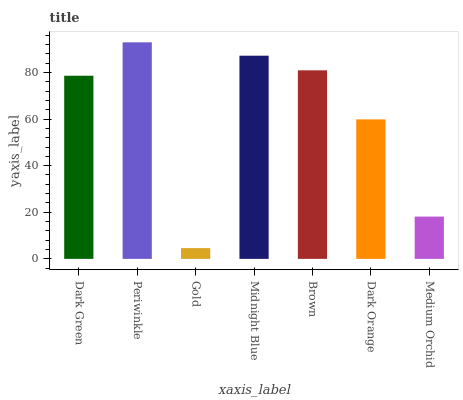Is Gold the minimum?
Answer yes or no. Yes. Is Periwinkle the maximum?
Answer yes or no. Yes. Is Periwinkle the minimum?
Answer yes or no. No. Is Gold the maximum?
Answer yes or no. No. Is Periwinkle greater than Gold?
Answer yes or no. Yes. Is Gold less than Periwinkle?
Answer yes or no. Yes. Is Gold greater than Periwinkle?
Answer yes or no. No. Is Periwinkle less than Gold?
Answer yes or no. No. Is Dark Green the high median?
Answer yes or no. Yes. Is Dark Green the low median?
Answer yes or no. Yes. Is Periwinkle the high median?
Answer yes or no. No. Is Periwinkle the low median?
Answer yes or no. No. 